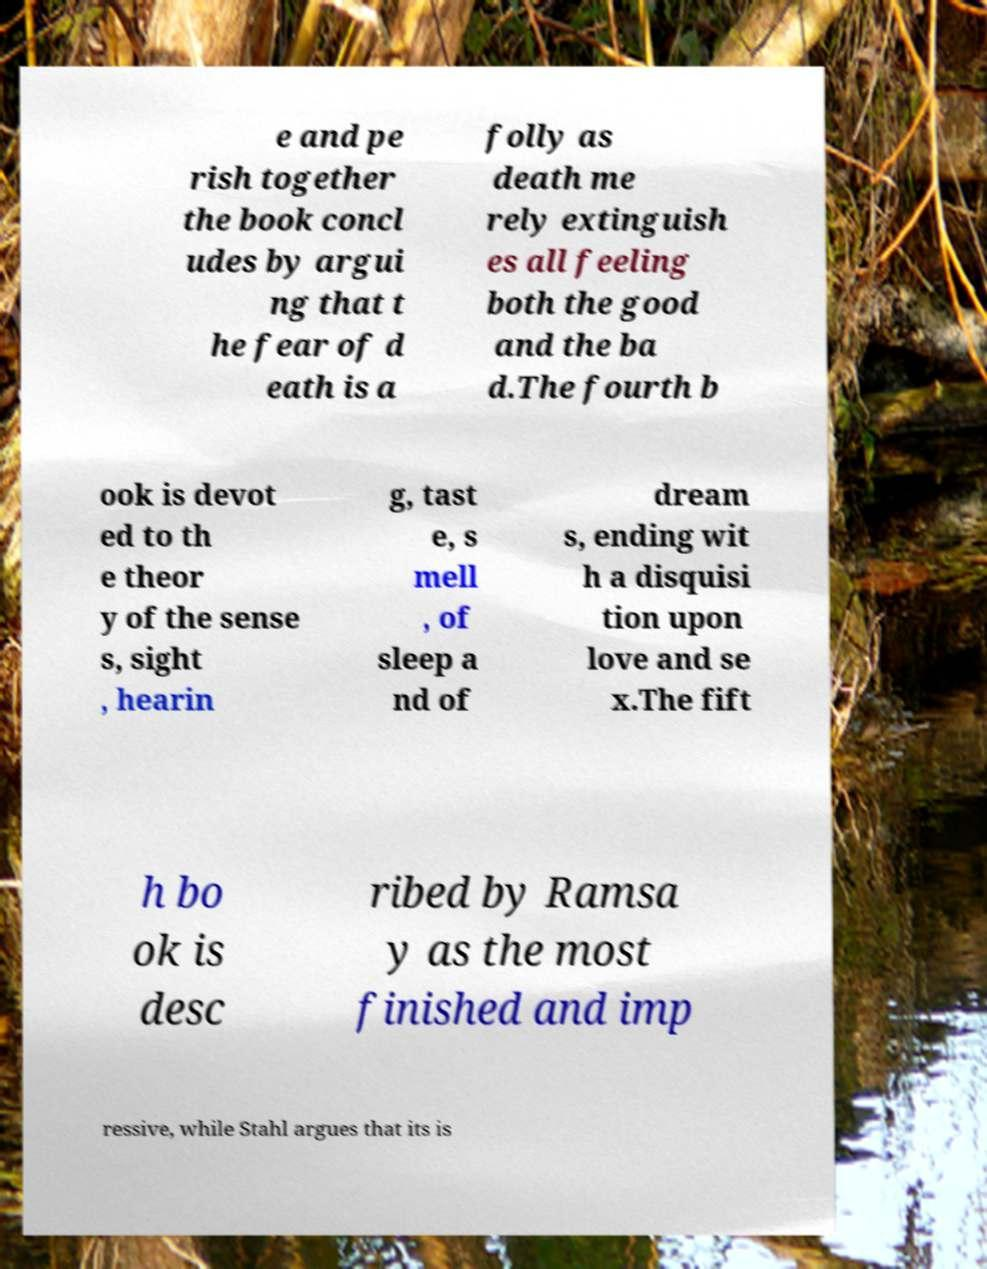Please read and relay the text visible in this image. What does it say? e and pe rish together the book concl udes by argui ng that t he fear of d eath is a folly as death me rely extinguish es all feeling both the good and the ba d.The fourth b ook is devot ed to th e theor y of the sense s, sight , hearin g, tast e, s mell , of sleep a nd of dream s, ending wit h a disquisi tion upon love and se x.The fift h bo ok is desc ribed by Ramsa y as the most finished and imp ressive, while Stahl argues that its is 